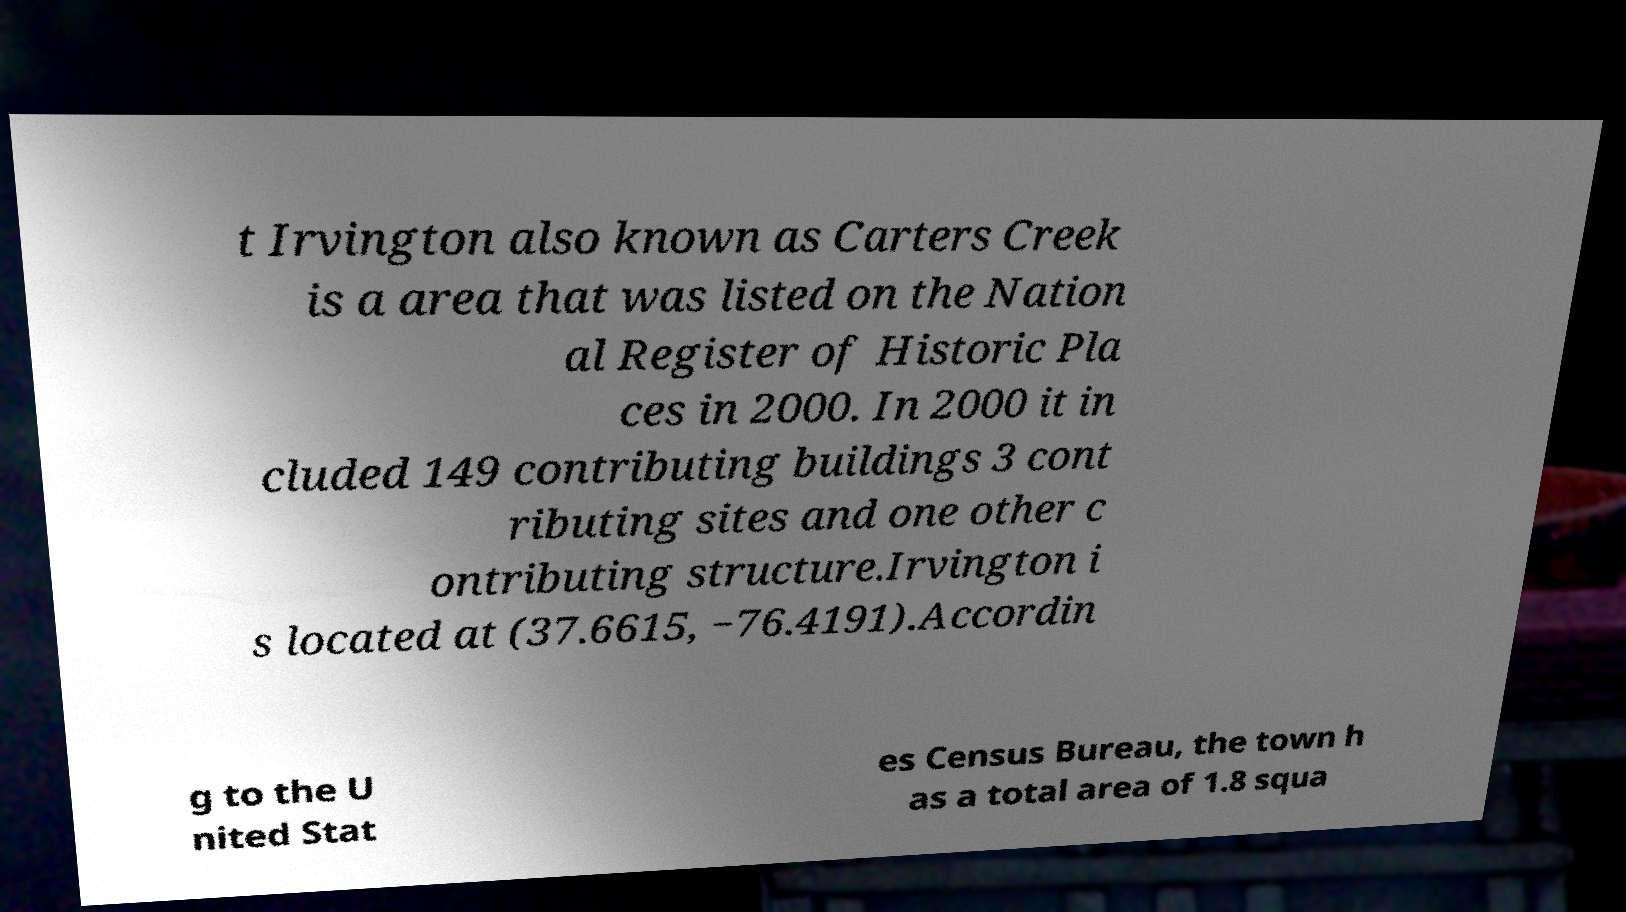Please read and relay the text visible in this image. What does it say? t Irvington also known as Carters Creek is a area that was listed on the Nation al Register of Historic Pla ces in 2000. In 2000 it in cluded 149 contributing buildings 3 cont ributing sites and one other c ontributing structure.Irvington i s located at (37.6615, −76.4191).Accordin g to the U nited Stat es Census Bureau, the town h as a total area of 1.8 squa 